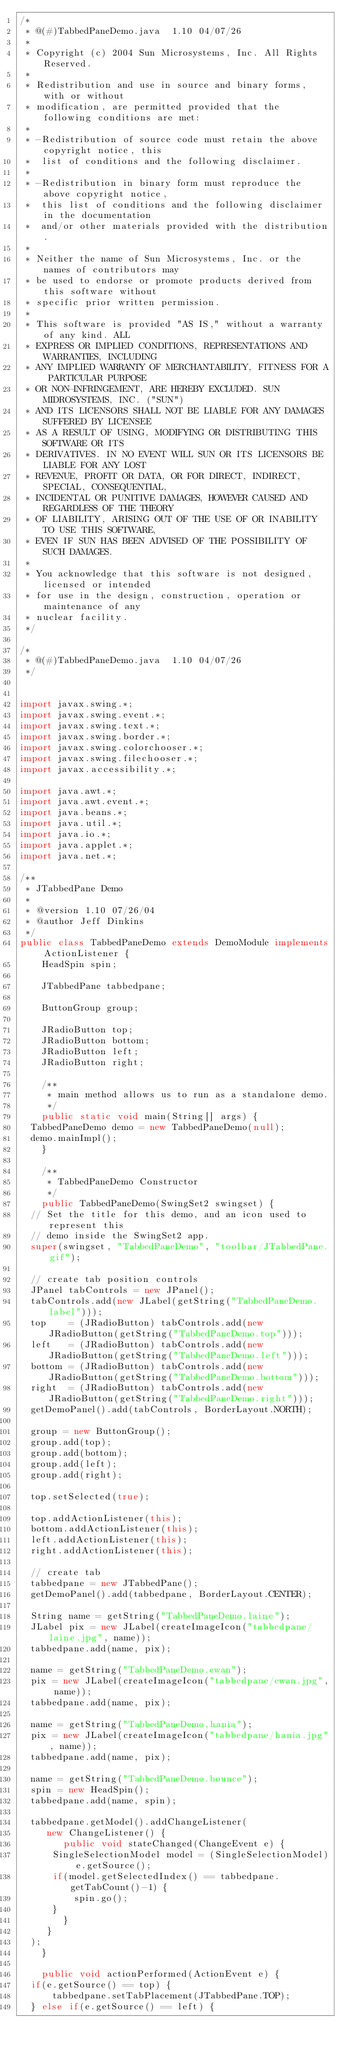<code> <loc_0><loc_0><loc_500><loc_500><_Java_>/*
 * @(#)TabbedPaneDemo.java	1.10 04/07/26
 * 
 * Copyright (c) 2004 Sun Microsystems, Inc. All Rights Reserved.
 * 
 * Redistribution and use in source and binary forms, with or without
 * modification, are permitted provided that the following conditions are met:
 * 
 * -Redistribution of source code must retain the above copyright notice, this
 *  list of conditions and the following disclaimer.
 * 
 * -Redistribution in binary form must reproduce the above copyright notice, 
 *  this list of conditions and the following disclaimer in the documentation
 *  and/or other materials provided with the distribution.
 * 
 * Neither the name of Sun Microsystems, Inc. or the names of contributors may 
 * be used to endorse or promote products derived from this software without 
 * specific prior written permission.
 * 
 * This software is provided "AS IS," without a warranty of any kind. ALL 
 * EXPRESS OR IMPLIED CONDITIONS, REPRESENTATIONS AND WARRANTIES, INCLUDING
 * ANY IMPLIED WARRANTY OF MERCHANTABILITY, FITNESS FOR A PARTICULAR PURPOSE
 * OR NON-INFRINGEMENT, ARE HEREBY EXCLUDED. SUN MIDROSYSTEMS, INC. ("SUN")
 * AND ITS LICENSORS SHALL NOT BE LIABLE FOR ANY DAMAGES SUFFERED BY LICENSEE
 * AS A RESULT OF USING, MODIFYING OR DISTRIBUTING THIS SOFTWARE OR ITS
 * DERIVATIVES. IN NO EVENT WILL SUN OR ITS LICENSORS BE LIABLE FOR ANY LOST 
 * REVENUE, PROFIT OR DATA, OR FOR DIRECT, INDIRECT, SPECIAL, CONSEQUENTIAL, 
 * INCIDENTAL OR PUNITIVE DAMAGES, HOWEVER CAUSED AND REGARDLESS OF THE THEORY 
 * OF LIABILITY, ARISING OUT OF THE USE OF OR INABILITY TO USE THIS SOFTWARE, 
 * EVEN IF SUN HAS BEEN ADVISED OF THE POSSIBILITY OF SUCH DAMAGES.
 * 
 * You acknowledge that this software is not designed, licensed or intended
 * for use in the design, construction, operation or maintenance of any
 * nuclear facility.
 */

/*
 * @(#)TabbedPaneDemo.java	1.10 04/07/26
 */


import javax.swing.*;
import javax.swing.event.*;
import javax.swing.text.*;
import javax.swing.border.*;
import javax.swing.colorchooser.*;
import javax.swing.filechooser.*;
import javax.accessibility.*;

import java.awt.*;
import java.awt.event.*;
import java.beans.*;
import java.util.*;
import java.io.*;
import java.applet.*;
import java.net.*;

/**
 * JTabbedPane Demo
 *
 * @version 1.10 07/26/04
 * @author Jeff Dinkins
 */
public class TabbedPaneDemo extends DemoModule implements ActionListener {
    HeadSpin spin;

    JTabbedPane tabbedpane;

    ButtonGroup group;

    JRadioButton top;
    JRadioButton bottom;
    JRadioButton left;
    JRadioButton right;

    /**
     * main method allows us to run as a standalone demo.
     */
    public static void main(String[] args) {
	TabbedPaneDemo demo = new TabbedPaneDemo(null);
	demo.mainImpl();
    }

    /**
     * TabbedPaneDemo Constructor
     */
    public TabbedPaneDemo(SwingSet2 swingset) {
	// Set the title for this demo, and an icon used to represent this
	// demo inside the SwingSet2 app.
	super(swingset, "TabbedPaneDemo", "toolbar/JTabbedPane.gif");

	// create tab position controls
	JPanel tabControls = new JPanel();
	tabControls.add(new JLabel(getString("TabbedPaneDemo.label")));
	top    = (JRadioButton) tabControls.add(new JRadioButton(getString("TabbedPaneDemo.top")));
	left   = (JRadioButton) tabControls.add(new JRadioButton(getString("TabbedPaneDemo.left")));
	bottom = (JRadioButton) tabControls.add(new JRadioButton(getString("TabbedPaneDemo.bottom")));
	right  = (JRadioButton) tabControls.add(new JRadioButton(getString("TabbedPaneDemo.right")));
	getDemoPanel().add(tabControls, BorderLayout.NORTH);

	group = new ButtonGroup();
	group.add(top);
	group.add(bottom);
	group.add(left);
	group.add(right);

	top.setSelected(true);

	top.addActionListener(this);
	bottom.addActionListener(this);
	left.addActionListener(this);
	right.addActionListener(this);

	// create tab 
	tabbedpane = new JTabbedPane();
	getDemoPanel().add(tabbedpane, BorderLayout.CENTER);

	String name = getString("TabbedPaneDemo.laine");
	JLabel pix = new JLabel(createImageIcon("tabbedpane/laine.jpg", name));
	tabbedpane.add(name, pix);

	name = getString("TabbedPaneDemo.ewan");
	pix = new JLabel(createImageIcon("tabbedpane/ewan.jpg", name));
	tabbedpane.add(name, pix);

	name = getString("TabbedPaneDemo.hania");
	pix = new JLabel(createImageIcon("tabbedpane/hania.jpg", name));
	tabbedpane.add(name, pix);

	name = getString("TabbedPaneDemo.bounce");
	spin = new HeadSpin();
	tabbedpane.add(name, spin);
	
	tabbedpane.getModel().addChangeListener(
	   new ChangeListener() {
	      public void stateChanged(ChangeEvent e) {
		  SingleSelectionModel model = (SingleSelectionModel) e.getSource();
		  if(model.getSelectedIndex() == tabbedpane.getTabCount()-1) {
		      spin.go();
		  }
	      }
	   }
	);
    }

    public void actionPerformed(ActionEvent e) {
	if(e.getSource() == top) {
	    tabbedpane.setTabPlacement(JTabbedPane.TOP);
	} else if(e.getSource() == left) {</code> 